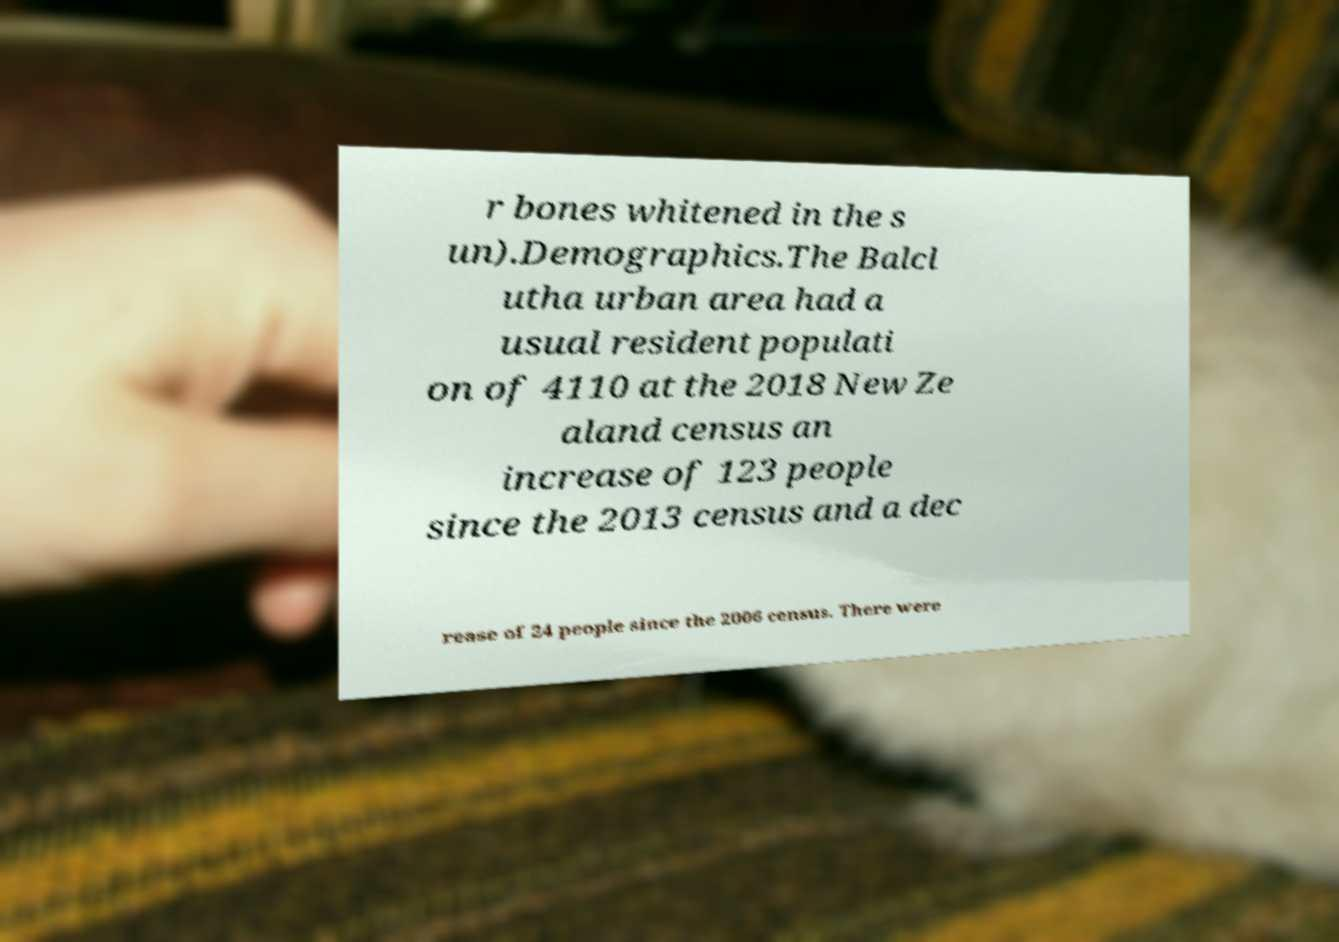There's text embedded in this image that I need extracted. Can you transcribe it verbatim? r bones whitened in the s un).Demographics.The Balcl utha urban area had a usual resident populati on of 4110 at the 2018 New Ze aland census an increase of 123 people since the 2013 census and a dec rease of 24 people since the 2006 census. There were 